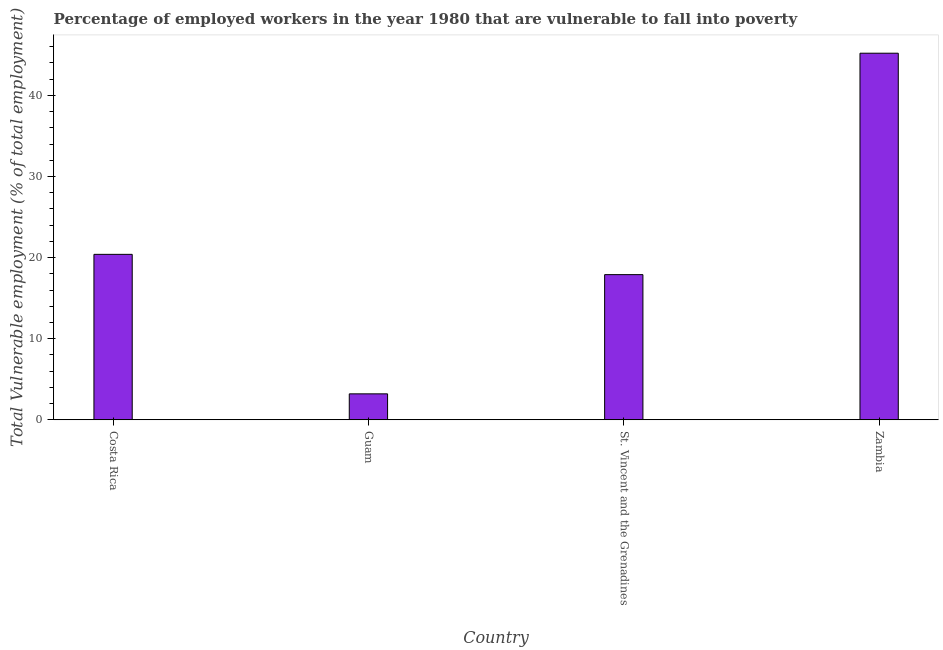What is the title of the graph?
Keep it short and to the point. Percentage of employed workers in the year 1980 that are vulnerable to fall into poverty. What is the label or title of the Y-axis?
Your answer should be very brief. Total Vulnerable employment (% of total employment). What is the total vulnerable employment in Zambia?
Your answer should be very brief. 45.2. Across all countries, what is the maximum total vulnerable employment?
Ensure brevity in your answer.  45.2. Across all countries, what is the minimum total vulnerable employment?
Ensure brevity in your answer.  3.2. In which country was the total vulnerable employment maximum?
Your response must be concise. Zambia. In which country was the total vulnerable employment minimum?
Your response must be concise. Guam. What is the sum of the total vulnerable employment?
Give a very brief answer. 86.7. What is the difference between the total vulnerable employment in Costa Rica and Zambia?
Make the answer very short. -24.8. What is the average total vulnerable employment per country?
Make the answer very short. 21.68. What is the median total vulnerable employment?
Your answer should be very brief. 19.15. What is the ratio of the total vulnerable employment in Costa Rica to that in St. Vincent and the Grenadines?
Give a very brief answer. 1.14. Is the total vulnerable employment in Guam less than that in Zambia?
Your answer should be very brief. Yes. Is the difference between the total vulnerable employment in Costa Rica and St. Vincent and the Grenadines greater than the difference between any two countries?
Provide a short and direct response. No. What is the difference between the highest and the second highest total vulnerable employment?
Give a very brief answer. 24.8. What is the difference between the highest and the lowest total vulnerable employment?
Give a very brief answer. 42. Are all the bars in the graph horizontal?
Provide a short and direct response. No. How many countries are there in the graph?
Make the answer very short. 4. What is the difference between two consecutive major ticks on the Y-axis?
Give a very brief answer. 10. Are the values on the major ticks of Y-axis written in scientific E-notation?
Make the answer very short. No. What is the Total Vulnerable employment (% of total employment) of Costa Rica?
Give a very brief answer. 20.4. What is the Total Vulnerable employment (% of total employment) of Guam?
Ensure brevity in your answer.  3.2. What is the Total Vulnerable employment (% of total employment) in St. Vincent and the Grenadines?
Make the answer very short. 17.9. What is the Total Vulnerable employment (% of total employment) of Zambia?
Your answer should be compact. 45.2. What is the difference between the Total Vulnerable employment (% of total employment) in Costa Rica and Zambia?
Your response must be concise. -24.8. What is the difference between the Total Vulnerable employment (% of total employment) in Guam and St. Vincent and the Grenadines?
Your answer should be very brief. -14.7. What is the difference between the Total Vulnerable employment (% of total employment) in Guam and Zambia?
Ensure brevity in your answer.  -42. What is the difference between the Total Vulnerable employment (% of total employment) in St. Vincent and the Grenadines and Zambia?
Give a very brief answer. -27.3. What is the ratio of the Total Vulnerable employment (% of total employment) in Costa Rica to that in Guam?
Ensure brevity in your answer.  6.38. What is the ratio of the Total Vulnerable employment (% of total employment) in Costa Rica to that in St. Vincent and the Grenadines?
Provide a short and direct response. 1.14. What is the ratio of the Total Vulnerable employment (% of total employment) in Costa Rica to that in Zambia?
Ensure brevity in your answer.  0.45. What is the ratio of the Total Vulnerable employment (% of total employment) in Guam to that in St. Vincent and the Grenadines?
Offer a terse response. 0.18. What is the ratio of the Total Vulnerable employment (% of total employment) in Guam to that in Zambia?
Your response must be concise. 0.07. What is the ratio of the Total Vulnerable employment (% of total employment) in St. Vincent and the Grenadines to that in Zambia?
Your answer should be very brief. 0.4. 